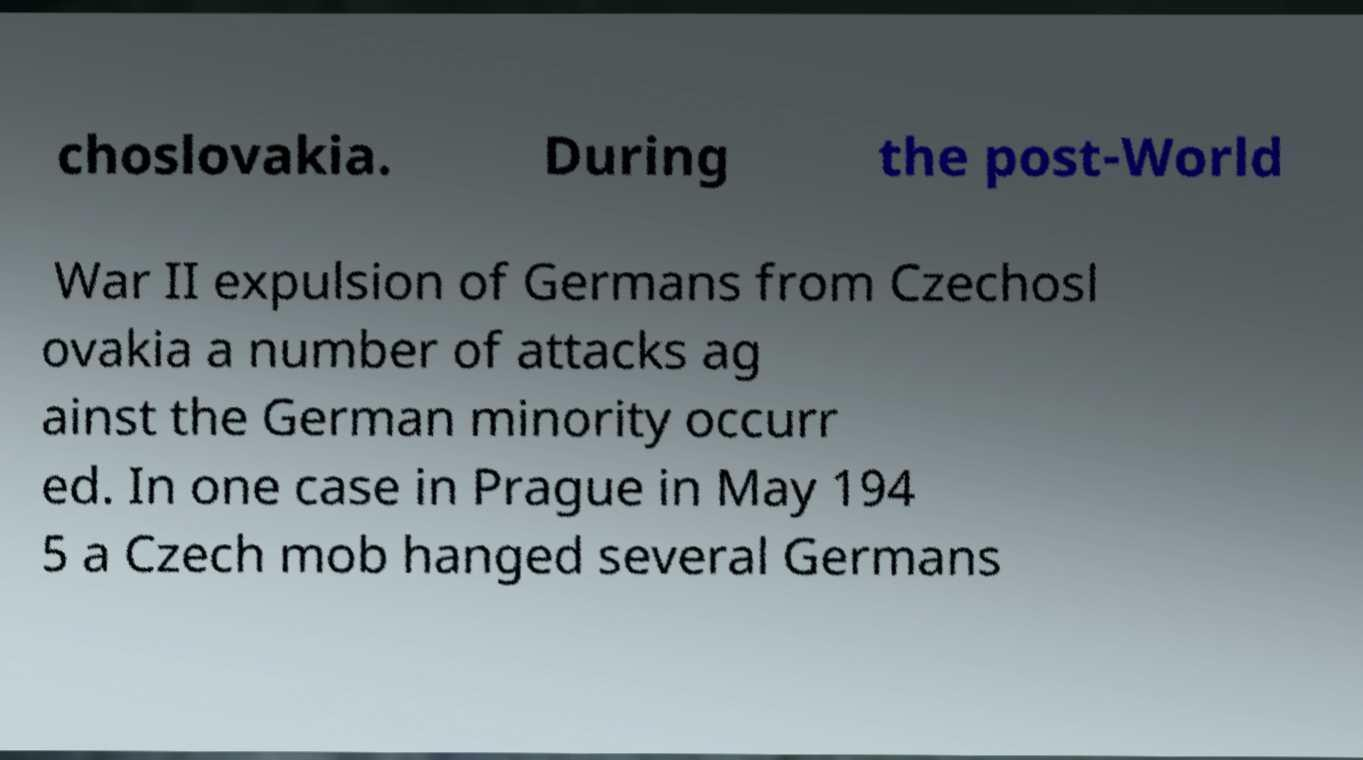Please identify and transcribe the text found in this image. choslovakia. During the post-World War II expulsion of Germans from Czechosl ovakia a number of attacks ag ainst the German minority occurr ed. In one case in Prague in May 194 5 a Czech mob hanged several Germans 